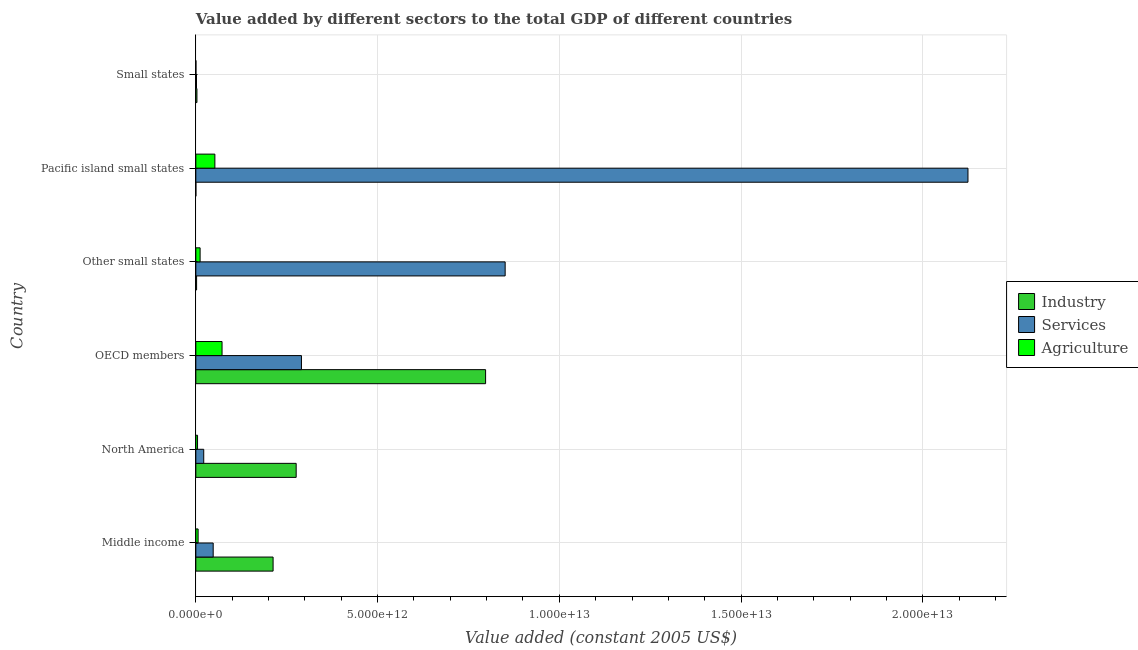How many groups of bars are there?
Provide a short and direct response. 6. Are the number of bars on each tick of the Y-axis equal?
Your answer should be very brief. Yes. How many bars are there on the 2nd tick from the bottom?
Give a very brief answer. 3. What is the value added by services in Small states?
Your answer should be compact. 1.83e+1. Across all countries, what is the maximum value added by industrial sector?
Offer a very short reply. 7.97e+12. Across all countries, what is the minimum value added by agricultural sector?
Your answer should be very brief. 3.11e+09. In which country was the value added by services maximum?
Ensure brevity in your answer.  Pacific island small states. In which country was the value added by industrial sector minimum?
Provide a short and direct response. Pacific island small states. What is the total value added by services in the graph?
Keep it short and to the point. 3.34e+13. What is the difference between the value added by industrial sector in OECD members and that in Pacific island small states?
Give a very brief answer. 7.97e+12. What is the difference between the value added by services in Small states and the value added by agricultural sector in Other small states?
Offer a very short reply. -9.94e+1. What is the average value added by services per country?
Offer a very short reply. 5.56e+12. What is the difference between the value added by industrial sector and value added by agricultural sector in Other small states?
Keep it short and to the point. -9.69e+1. What is the ratio of the value added by agricultural sector in North America to that in Small states?
Your answer should be compact. 15.22. What is the difference between the highest and the second highest value added by industrial sector?
Offer a terse response. 5.21e+12. What is the difference between the highest and the lowest value added by industrial sector?
Your response must be concise. 7.97e+12. What does the 3rd bar from the top in Pacific island small states represents?
Keep it short and to the point. Industry. What does the 2nd bar from the bottom in Small states represents?
Make the answer very short. Services. Are all the bars in the graph horizontal?
Provide a short and direct response. Yes. What is the difference between two consecutive major ticks on the X-axis?
Offer a very short reply. 5.00e+12. Are the values on the major ticks of X-axis written in scientific E-notation?
Keep it short and to the point. Yes. Does the graph contain any zero values?
Provide a short and direct response. No. Does the graph contain grids?
Ensure brevity in your answer.  Yes. Where does the legend appear in the graph?
Your response must be concise. Center right. How many legend labels are there?
Your answer should be compact. 3. How are the legend labels stacked?
Ensure brevity in your answer.  Vertical. What is the title of the graph?
Ensure brevity in your answer.  Value added by different sectors to the total GDP of different countries. What is the label or title of the X-axis?
Give a very brief answer. Value added (constant 2005 US$). What is the label or title of the Y-axis?
Keep it short and to the point. Country. What is the Value added (constant 2005 US$) of Industry in Middle income?
Your response must be concise. 2.13e+12. What is the Value added (constant 2005 US$) of Services in Middle income?
Provide a short and direct response. 4.78e+11. What is the Value added (constant 2005 US$) of Agriculture in Middle income?
Ensure brevity in your answer.  6.26e+1. What is the Value added (constant 2005 US$) of Industry in North America?
Offer a very short reply. 2.76e+12. What is the Value added (constant 2005 US$) in Services in North America?
Your answer should be very brief. 2.18e+11. What is the Value added (constant 2005 US$) in Agriculture in North America?
Make the answer very short. 4.74e+1. What is the Value added (constant 2005 US$) in Industry in OECD members?
Ensure brevity in your answer.  7.97e+12. What is the Value added (constant 2005 US$) in Services in OECD members?
Your answer should be very brief. 2.91e+12. What is the Value added (constant 2005 US$) of Agriculture in OECD members?
Give a very brief answer. 7.21e+11. What is the Value added (constant 2005 US$) in Industry in Other small states?
Provide a short and direct response. 2.08e+1. What is the Value added (constant 2005 US$) in Services in Other small states?
Provide a succinct answer. 8.51e+12. What is the Value added (constant 2005 US$) of Agriculture in Other small states?
Offer a very short reply. 1.18e+11. What is the Value added (constant 2005 US$) in Industry in Pacific island small states?
Keep it short and to the point. 7.67e+08. What is the Value added (constant 2005 US$) of Services in Pacific island small states?
Make the answer very short. 2.12e+13. What is the Value added (constant 2005 US$) in Agriculture in Pacific island small states?
Your answer should be very brief. 5.24e+11. What is the Value added (constant 2005 US$) in Industry in Small states?
Keep it short and to the point. 3.05e+1. What is the Value added (constant 2005 US$) of Services in Small states?
Provide a succinct answer. 1.83e+1. What is the Value added (constant 2005 US$) of Agriculture in Small states?
Provide a succinct answer. 3.11e+09. Across all countries, what is the maximum Value added (constant 2005 US$) in Industry?
Provide a succinct answer. 7.97e+12. Across all countries, what is the maximum Value added (constant 2005 US$) of Services?
Your answer should be compact. 2.12e+13. Across all countries, what is the maximum Value added (constant 2005 US$) of Agriculture?
Make the answer very short. 7.21e+11. Across all countries, what is the minimum Value added (constant 2005 US$) in Industry?
Keep it short and to the point. 7.67e+08. Across all countries, what is the minimum Value added (constant 2005 US$) of Services?
Offer a very short reply. 1.83e+1. Across all countries, what is the minimum Value added (constant 2005 US$) in Agriculture?
Your answer should be compact. 3.11e+09. What is the total Value added (constant 2005 US$) of Industry in the graph?
Your answer should be compact. 1.29e+13. What is the total Value added (constant 2005 US$) of Services in the graph?
Ensure brevity in your answer.  3.34e+13. What is the total Value added (constant 2005 US$) in Agriculture in the graph?
Keep it short and to the point. 1.48e+12. What is the difference between the Value added (constant 2005 US$) of Industry in Middle income and that in North America?
Provide a short and direct response. -6.35e+11. What is the difference between the Value added (constant 2005 US$) in Services in Middle income and that in North America?
Your answer should be very brief. 2.60e+11. What is the difference between the Value added (constant 2005 US$) in Agriculture in Middle income and that in North America?
Your answer should be compact. 1.53e+1. What is the difference between the Value added (constant 2005 US$) in Industry in Middle income and that in OECD members?
Provide a succinct answer. -5.85e+12. What is the difference between the Value added (constant 2005 US$) in Services in Middle income and that in OECD members?
Make the answer very short. -2.43e+12. What is the difference between the Value added (constant 2005 US$) in Agriculture in Middle income and that in OECD members?
Make the answer very short. -6.59e+11. What is the difference between the Value added (constant 2005 US$) of Industry in Middle income and that in Other small states?
Offer a terse response. 2.10e+12. What is the difference between the Value added (constant 2005 US$) in Services in Middle income and that in Other small states?
Your answer should be very brief. -8.03e+12. What is the difference between the Value added (constant 2005 US$) in Agriculture in Middle income and that in Other small states?
Give a very brief answer. -5.51e+1. What is the difference between the Value added (constant 2005 US$) in Industry in Middle income and that in Pacific island small states?
Give a very brief answer. 2.12e+12. What is the difference between the Value added (constant 2005 US$) of Services in Middle income and that in Pacific island small states?
Provide a succinct answer. -2.08e+13. What is the difference between the Value added (constant 2005 US$) of Agriculture in Middle income and that in Pacific island small states?
Your answer should be compact. -4.61e+11. What is the difference between the Value added (constant 2005 US$) of Industry in Middle income and that in Small states?
Provide a succinct answer. 2.10e+12. What is the difference between the Value added (constant 2005 US$) of Services in Middle income and that in Small states?
Provide a succinct answer. 4.59e+11. What is the difference between the Value added (constant 2005 US$) in Agriculture in Middle income and that in Small states?
Ensure brevity in your answer.  5.95e+1. What is the difference between the Value added (constant 2005 US$) of Industry in North America and that in OECD members?
Ensure brevity in your answer.  -5.21e+12. What is the difference between the Value added (constant 2005 US$) of Services in North America and that in OECD members?
Give a very brief answer. -2.69e+12. What is the difference between the Value added (constant 2005 US$) in Agriculture in North America and that in OECD members?
Give a very brief answer. -6.74e+11. What is the difference between the Value added (constant 2005 US$) of Industry in North America and that in Other small states?
Keep it short and to the point. 2.74e+12. What is the difference between the Value added (constant 2005 US$) of Services in North America and that in Other small states?
Offer a terse response. -8.29e+12. What is the difference between the Value added (constant 2005 US$) in Agriculture in North America and that in Other small states?
Provide a succinct answer. -7.04e+1. What is the difference between the Value added (constant 2005 US$) of Industry in North America and that in Pacific island small states?
Provide a succinct answer. 2.76e+12. What is the difference between the Value added (constant 2005 US$) in Services in North America and that in Pacific island small states?
Your response must be concise. -2.10e+13. What is the difference between the Value added (constant 2005 US$) in Agriculture in North America and that in Pacific island small states?
Your response must be concise. -4.76e+11. What is the difference between the Value added (constant 2005 US$) in Industry in North America and that in Small states?
Offer a very short reply. 2.73e+12. What is the difference between the Value added (constant 2005 US$) of Services in North America and that in Small states?
Provide a short and direct response. 1.99e+11. What is the difference between the Value added (constant 2005 US$) in Agriculture in North America and that in Small states?
Offer a terse response. 4.42e+1. What is the difference between the Value added (constant 2005 US$) in Industry in OECD members and that in Other small states?
Keep it short and to the point. 7.95e+12. What is the difference between the Value added (constant 2005 US$) in Services in OECD members and that in Other small states?
Offer a very short reply. -5.60e+12. What is the difference between the Value added (constant 2005 US$) of Agriculture in OECD members and that in Other small states?
Your answer should be compact. 6.04e+11. What is the difference between the Value added (constant 2005 US$) in Industry in OECD members and that in Pacific island small states?
Provide a short and direct response. 7.97e+12. What is the difference between the Value added (constant 2005 US$) of Services in OECD members and that in Pacific island small states?
Provide a short and direct response. -1.83e+13. What is the difference between the Value added (constant 2005 US$) of Agriculture in OECD members and that in Pacific island small states?
Provide a succinct answer. 1.97e+11. What is the difference between the Value added (constant 2005 US$) of Industry in OECD members and that in Small states?
Give a very brief answer. 7.94e+12. What is the difference between the Value added (constant 2005 US$) of Services in OECD members and that in Small states?
Make the answer very short. 2.89e+12. What is the difference between the Value added (constant 2005 US$) of Agriculture in OECD members and that in Small states?
Provide a short and direct response. 7.18e+11. What is the difference between the Value added (constant 2005 US$) of Industry in Other small states and that in Pacific island small states?
Your response must be concise. 2.01e+1. What is the difference between the Value added (constant 2005 US$) of Services in Other small states and that in Pacific island small states?
Your response must be concise. -1.27e+13. What is the difference between the Value added (constant 2005 US$) of Agriculture in Other small states and that in Pacific island small states?
Your answer should be compact. -4.06e+11. What is the difference between the Value added (constant 2005 US$) in Industry in Other small states and that in Small states?
Your answer should be very brief. -9.62e+09. What is the difference between the Value added (constant 2005 US$) of Services in Other small states and that in Small states?
Provide a short and direct response. 8.49e+12. What is the difference between the Value added (constant 2005 US$) in Agriculture in Other small states and that in Small states?
Offer a very short reply. 1.15e+11. What is the difference between the Value added (constant 2005 US$) of Industry in Pacific island small states and that in Small states?
Your answer should be compact. -2.97e+1. What is the difference between the Value added (constant 2005 US$) in Services in Pacific island small states and that in Small states?
Your answer should be very brief. 2.12e+13. What is the difference between the Value added (constant 2005 US$) in Agriculture in Pacific island small states and that in Small states?
Offer a terse response. 5.21e+11. What is the difference between the Value added (constant 2005 US$) of Industry in Middle income and the Value added (constant 2005 US$) of Services in North America?
Ensure brevity in your answer.  1.91e+12. What is the difference between the Value added (constant 2005 US$) of Industry in Middle income and the Value added (constant 2005 US$) of Agriculture in North America?
Provide a short and direct response. 2.08e+12. What is the difference between the Value added (constant 2005 US$) in Services in Middle income and the Value added (constant 2005 US$) in Agriculture in North America?
Give a very brief answer. 4.30e+11. What is the difference between the Value added (constant 2005 US$) in Industry in Middle income and the Value added (constant 2005 US$) in Services in OECD members?
Provide a short and direct response. -7.80e+11. What is the difference between the Value added (constant 2005 US$) in Industry in Middle income and the Value added (constant 2005 US$) in Agriculture in OECD members?
Make the answer very short. 1.40e+12. What is the difference between the Value added (constant 2005 US$) in Services in Middle income and the Value added (constant 2005 US$) in Agriculture in OECD members?
Offer a very short reply. -2.44e+11. What is the difference between the Value added (constant 2005 US$) in Industry in Middle income and the Value added (constant 2005 US$) in Services in Other small states?
Your response must be concise. -6.38e+12. What is the difference between the Value added (constant 2005 US$) of Industry in Middle income and the Value added (constant 2005 US$) of Agriculture in Other small states?
Make the answer very short. 2.01e+12. What is the difference between the Value added (constant 2005 US$) in Services in Middle income and the Value added (constant 2005 US$) in Agriculture in Other small states?
Offer a very short reply. 3.60e+11. What is the difference between the Value added (constant 2005 US$) in Industry in Middle income and the Value added (constant 2005 US$) in Services in Pacific island small states?
Make the answer very short. -1.91e+13. What is the difference between the Value added (constant 2005 US$) in Industry in Middle income and the Value added (constant 2005 US$) in Agriculture in Pacific island small states?
Offer a very short reply. 1.60e+12. What is the difference between the Value added (constant 2005 US$) in Services in Middle income and the Value added (constant 2005 US$) in Agriculture in Pacific island small states?
Give a very brief answer. -4.62e+1. What is the difference between the Value added (constant 2005 US$) of Industry in Middle income and the Value added (constant 2005 US$) of Services in Small states?
Provide a succinct answer. 2.11e+12. What is the difference between the Value added (constant 2005 US$) in Industry in Middle income and the Value added (constant 2005 US$) in Agriculture in Small states?
Your answer should be very brief. 2.12e+12. What is the difference between the Value added (constant 2005 US$) of Services in Middle income and the Value added (constant 2005 US$) of Agriculture in Small states?
Make the answer very short. 4.75e+11. What is the difference between the Value added (constant 2005 US$) of Industry in North America and the Value added (constant 2005 US$) of Services in OECD members?
Your answer should be compact. -1.45e+11. What is the difference between the Value added (constant 2005 US$) of Industry in North America and the Value added (constant 2005 US$) of Agriculture in OECD members?
Your response must be concise. 2.04e+12. What is the difference between the Value added (constant 2005 US$) in Services in North America and the Value added (constant 2005 US$) in Agriculture in OECD members?
Your response must be concise. -5.04e+11. What is the difference between the Value added (constant 2005 US$) of Industry in North America and the Value added (constant 2005 US$) of Services in Other small states?
Your answer should be compact. -5.75e+12. What is the difference between the Value added (constant 2005 US$) of Industry in North America and the Value added (constant 2005 US$) of Agriculture in Other small states?
Ensure brevity in your answer.  2.64e+12. What is the difference between the Value added (constant 2005 US$) of Services in North America and the Value added (constant 2005 US$) of Agriculture in Other small states?
Offer a very short reply. 9.98e+1. What is the difference between the Value added (constant 2005 US$) of Industry in North America and the Value added (constant 2005 US$) of Services in Pacific island small states?
Provide a short and direct response. -1.85e+13. What is the difference between the Value added (constant 2005 US$) of Industry in North America and the Value added (constant 2005 US$) of Agriculture in Pacific island small states?
Provide a short and direct response. 2.24e+12. What is the difference between the Value added (constant 2005 US$) of Services in North America and the Value added (constant 2005 US$) of Agriculture in Pacific island small states?
Ensure brevity in your answer.  -3.06e+11. What is the difference between the Value added (constant 2005 US$) of Industry in North America and the Value added (constant 2005 US$) of Services in Small states?
Give a very brief answer. 2.74e+12. What is the difference between the Value added (constant 2005 US$) in Industry in North America and the Value added (constant 2005 US$) in Agriculture in Small states?
Offer a very short reply. 2.76e+12. What is the difference between the Value added (constant 2005 US$) in Services in North America and the Value added (constant 2005 US$) in Agriculture in Small states?
Provide a succinct answer. 2.14e+11. What is the difference between the Value added (constant 2005 US$) in Industry in OECD members and the Value added (constant 2005 US$) in Services in Other small states?
Keep it short and to the point. -5.38e+11. What is the difference between the Value added (constant 2005 US$) of Industry in OECD members and the Value added (constant 2005 US$) of Agriculture in Other small states?
Provide a succinct answer. 7.85e+12. What is the difference between the Value added (constant 2005 US$) of Services in OECD members and the Value added (constant 2005 US$) of Agriculture in Other small states?
Your response must be concise. 2.79e+12. What is the difference between the Value added (constant 2005 US$) in Industry in OECD members and the Value added (constant 2005 US$) in Services in Pacific island small states?
Your answer should be very brief. -1.33e+13. What is the difference between the Value added (constant 2005 US$) of Industry in OECD members and the Value added (constant 2005 US$) of Agriculture in Pacific island small states?
Offer a terse response. 7.45e+12. What is the difference between the Value added (constant 2005 US$) in Services in OECD members and the Value added (constant 2005 US$) in Agriculture in Pacific island small states?
Provide a succinct answer. 2.38e+12. What is the difference between the Value added (constant 2005 US$) in Industry in OECD members and the Value added (constant 2005 US$) in Services in Small states?
Give a very brief answer. 7.95e+12. What is the difference between the Value added (constant 2005 US$) of Industry in OECD members and the Value added (constant 2005 US$) of Agriculture in Small states?
Offer a very short reply. 7.97e+12. What is the difference between the Value added (constant 2005 US$) of Services in OECD members and the Value added (constant 2005 US$) of Agriculture in Small states?
Your response must be concise. 2.90e+12. What is the difference between the Value added (constant 2005 US$) in Industry in Other small states and the Value added (constant 2005 US$) in Services in Pacific island small states?
Make the answer very short. -2.12e+13. What is the difference between the Value added (constant 2005 US$) of Industry in Other small states and the Value added (constant 2005 US$) of Agriculture in Pacific island small states?
Give a very brief answer. -5.03e+11. What is the difference between the Value added (constant 2005 US$) in Services in Other small states and the Value added (constant 2005 US$) in Agriculture in Pacific island small states?
Offer a terse response. 7.99e+12. What is the difference between the Value added (constant 2005 US$) of Industry in Other small states and the Value added (constant 2005 US$) of Services in Small states?
Your answer should be compact. 2.49e+09. What is the difference between the Value added (constant 2005 US$) of Industry in Other small states and the Value added (constant 2005 US$) of Agriculture in Small states?
Your answer should be compact. 1.77e+1. What is the difference between the Value added (constant 2005 US$) of Services in Other small states and the Value added (constant 2005 US$) of Agriculture in Small states?
Your answer should be compact. 8.51e+12. What is the difference between the Value added (constant 2005 US$) of Industry in Pacific island small states and the Value added (constant 2005 US$) of Services in Small states?
Give a very brief answer. -1.76e+1. What is the difference between the Value added (constant 2005 US$) in Industry in Pacific island small states and the Value added (constant 2005 US$) in Agriculture in Small states?
Provide a short and direct response. -2.34e+09. What is the difference between the Value added (constant 2005 US$) of Services in Pacific island small states and the Value added (constant 2005 US$) of Agriculture in Small states?
Provide a succinct answer. 2.12e+13. What is the average Value added (constant 2005 US$) in Industry per country?
Offer a very short reply. 2.15e+12. What is the average Value added (constant 2005 US$) in Services per country?
Ensure brevity in your answer.  5.56e+12. What is the average Value added (constant 2005 US$) of Agriculture per country?
Offer a terse response. 2.46e+11. What is the difference between the Value added (constant 2005 US$) in Industry and Value added (constant 2005 US$) in Services in Middle income?
Make the answer very short. 1.65e+12. What is the difference between the Value added (constant 2005 US$) in Industry and Value added (constant 2005 US$) in Agriculture in Middle income?
Provide a succinct answer. 2.06e+12. What is the difference between the Value added (constant 2005 US$) in Services and Value added (constant 2005 US$) in Agriculture in Middle income?
Keep it short and to the point. 4.15e+11. What is the difference between the Value added (constant 2005 US$) of Industry and Value added (constant 2005 US$) of Services in North America?
Make the answer very short. 2.54e+12. What is the difference between the Value added (constant 2005 US$) in Industry and Value added (constant 2005 US$) in Agriculture in North America?
Give a very brief answer. 2.71e+12. What is the difference between the Value added (constant 2005 US$) of Services and Value added (constant 2005 US$) of Agriculture in North America?
Offer a terse response. 1.70e+11. What is the difference between the Value added (constant 2005 US$) of Industry and Value added (constant 2005 US$) of Services in OECD members?
Offer a very short reply. 5.07e+12. What is the difference between the Value added (constant 2005 US$) in Industry and Value added (constant 2005 US$) in Agriculture in OECD members?
Ensure brevity in your answer.  7.25e+12. What is the difference between the Value added (constant 2005 US$) in Services and Value added (constant 2005 US$) in Agriculture in OECD members?
Make the answer very short. 2.18e+12. What is the difference between the Value added (constant 2005 US$) of Industry and Value added (constant 2005 US$) of Services in Other small states?
Make the answer very short. -8.49e+12. What is the difference between the Value added (constant 2005 US$) of Industry and Value added (constant 2005 US$) of Agriculture in Other small states?
Offer a terse response. -9.69e+1. What is the difference between the Value added (constant 2005 US$) in Services and Value added (constant 2005 US$) in Agriculture in Other small states?
Offer a terse response. 8.39e+12. What is the difference between the Value added (constant 2005 US$) in Industry and Value added (constant 2005 US$) in Services in Pacific island small states?
Offer a very short reply. -2.12e+13. What is the difference between the Value added (constant 2005 US$) of Industry and Value added (constant 2005 US$) of Agriculture in Pacific island small states?
Ensure brevity in your answer.  -5.23e+11. What is the difference between the Value added (constant 2005 US$) of Services and Value added (constant 2005 US$) of Agriculture in Pacific island small states?
Give a very brief answer. 2.07e+13. What is the difference between the Value added (constant 2005 US$) of Industry and Value added (constant 2005 US$) of Services in Small states?
Your answer should be compact. 1.21e+1. What is the difference between the Value added (constant 2005 US$) of Industry and Value added (constant 2005 US$) of Agriculture in Small states?
Offer a very short reply. 2.73e+1. What is the difference between the Value added (constant 2005 US$) of Services and Value added (constant 2005 US$) of Agriculture in Small states?
Offer a terse response. 1.52e+1. What is the ratio of the Value added (constant 2005 US$) of Industry in Middle income to that in North America?
Your response must be concise. 0.77. What is the ratio of the Value added (constant 2005 US$) in Services in Middle income to that in North America?
Offer a very short reply. 2.2. What is the ratio of the Value added (constant 2005 US$) of Agriculture in Middle income to that in North America?
Give a very brief answer. 1.32. What is the ratio of the Value added (constant 2005 US$) of Industry in Middle income to that in OECD members?
Your answer should be compact. 0.27. What is the ratio of the Value added (constant 2005 US$) of Services in Middle income to that in OECD members?
Give a very brief answer. 0.16. What is the ratio of the Value added (constant 2005 US$) of Agriculture in Middle income to that in OECD members?
Your answer should be compact. 0.09. What is the ratio of the Value added (constant 2005 US$) in Industry in Middle income to that in Other small states?
Offer a terse response. 102.03. What is the ratio of the Value added (constant 2005 US$) in Services in Middle income to that in Other small states?
Give a very brief answer. 0.06. What is the ratio of the Value added (constant 2005 US$) of Agriculture in Middle income to that in Other small states?
Offer a very short reply. 0.53. What is the ratio of the Value added (constant 2005 US$) in Industry in Middle income to that in Pacific island small states?
Your answer should be compact. 2769.79. What is the ratio of the Value added (constant 2005 US$) in Services in Middle income to that in Pacific island small states?
Offer a very short reply. 0.02. What is the ratio of the Value added (constant 2005 US$) in Agriculture in Middle income to that in Pacific island small states?
Provide a succinct answer. 0.12. What is the ratio of the Value added (constant 2005 US$) in Industry in Middle income to that in Small states?
Your answer should be compact. 69.8. What is the ratio of the Value added (constant 2005 US$) of Services in Middle income to that in Small states?
Your answer should be compact. 26.04. What is the ratio of the Value added (constant 2005 US$) in Agriculture in Middle income to that in Small states?
Your answer should be very brief. 20.14. What is the ratio of the Value added (constant 2005 US$) of Industry in North America to that in OECD members?
Offer a very short reply. 0.35. What is the ratio of the Value added (constant 2005 US$) in Services in North America to that in OECD members?
Your response must be concise. 0.07. What is the ratio of the Value added (constant 2005 US$) of Agriculture in North America to that in OECD members?
Give a very brief answer. 0.07. What is the ratio of the Value added (constant 2005 US$) in Industry in North America to that in Other small states?
Give a very brief answer. 132.51. What is the ratio of the Value added (constant 2005 US$) in Services in North America to that in Other small states?
Make the answer very short. 0.03. What is the ratio of the Value added (constant 2005 US$) in Agriculture in North America to that in Other small states?
Provide a short and direct response. 0.4. What is the ratio of the Value added (constant 2005 US$) in Industry in North America to that in Pacific island small states?
Your answer should be very brief. 3597.25. What is the ratio of the Value added (constant 2005 US$) of Services in North America to that in Pacific island small states?
Ensure brevity in your answer.  0.01. What is the ratio of the Value added (constant 2005 US$) in Agriculture in North America to that in Pacific island small states?
Make the answer very short. 0.09. What is the ratio of the Value added (constant 2005 US$) of Industry in North America to that in Small states?
Offer a terse response. 90.65. What is the ratio of the Value added (constant 2005 US$) in Services in North America to that in Small states?
Offer a very short reply. 11.86. What is the ratio of the Value added (constant 2005 US$) of Agriculture in North America to that in Small states?
Provide a short and direct response. 15.22. What is the ratio of the Value added (constant 2005 US$) of Industry in OECD members to that in Other small states?
Give a very brief answer. 382.65. What is the ratio of the Value added (constant 2005 US$) of Services in OECD members to that in Other small states?
Give a very brief answer. 0.34. What is the ratio of the Value added (constant 2005 US$) of Agriculture in OECD members to that in Other small states?
Provide a succinct answer. 6.13. What is the ratio of the Value added (constant 2005 US$) in Industry in OECD members to that in Pacific island small states?
Your answer should be very brief. 1.04e+04. What is the ratio of the Value added (constant 2005 US$) in Services in OECD members to that in Pacific island small states?
Keep it short and to the point. 0.14. What is the ratio of the Value added (constant 2005 US$) in Agriculture in OECD members to that in Pacific island small states?
Keep it short and to the point. 1.38. What is the ratio of the Value added (constant 2005 US$) of Industry in OECD members to that in Small states?
Make the answer very short. 261.79. What is the ratio of the Value added (constant 2005 US$) in Services in OECD members to that in Small states?
Your answer should be compact. 158.4. What is the ratio of the Value added (constant 2005 US$) in Agriculture in OECD members to that in Small states?
Make the answer very short. 231.84. What is the ratio of the Value added (constant 2005 US$) in Industry in Other small states to that in Pacific island small states?
Offer a terse response. 27.15. What is the ratio of the Value added (constant 2005 US$) in Services in Other small states to that in Pacific island small states?
Offer a terse response. 0.4. What is the ratio of the Value added (constant 2005 US$) in Agriculture in Other small states to that in Pacific island small states?
Your answer should be very brief. 0.22. What is the ratio of the Value added (constant 2005 US$) of Industry in Other small states to that in Small states?
Your response must be concise. 0.68. What is the ratio of the Value added (constant 2005 US$) of Services in Other small states to that in Small states?
Provide a short and direct response. 463.87. What is the ratio of the Value added (constant 2005 US$) in Agriculture in Other small states to that in Small states?
Provide a succinct answer. 37.83. What is the ratio of the Value added (constant 2005 US$) in Industry in Pacific island small states to that in Small states?
Ensure brevity in your answer.  0.03. What is the ratio of the Value added (constant 2005 US$) in Services in Pacific island small states to that in Small states?
Give a very brief answer. 1157.92. What is the ratio of the Value added (constant 2005 US$) of Agriculture in Pacific island small states to that in Small states?
Offer a terse response. 168.36. What is the difference between the highest and the second highest Value added (constant 2005 US$) of Industry?
Give a very brief answer. 5.21e+12. What is the difference between the highest and the second highest Value added (constant 2005 US$) of Services?
Your answer should be very brief. 1.27e+13. What is the difference between the highest and the second highest Value added (constant 2005 US$) of Agriculture?
Make the answer very short. 1.97e+11. What is the difference between the highest and the lowest Value added (constant 2005 US$) of Industry?
Provide a short and direct response. 7.97e+12. What is the difference between the highest and the lowest Value added (constant 2005 US$) in Services?
Offer a very short reply. 2.12e+13. What is the difference between the highest and the lowest Value added (constant 2005 US$) in Agriculture?
Offer a very short reply. 7.18e+11. 